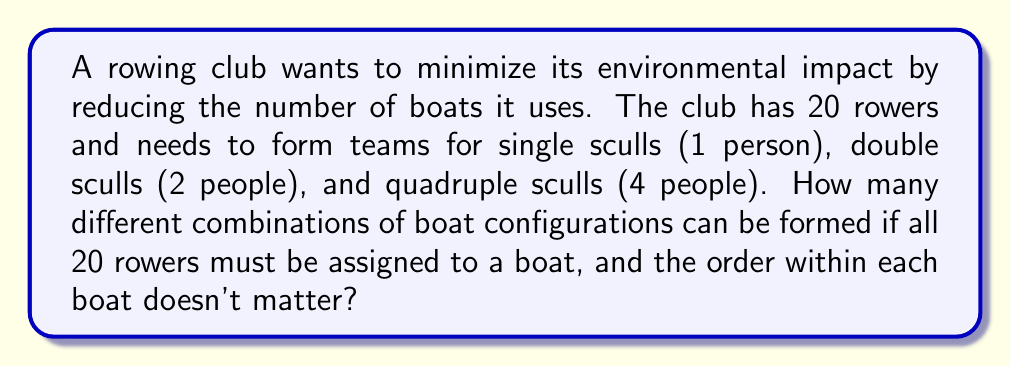Can you solve this math problem? Let's approach this step-by-step:

1) Let $x$, $y$, and $z$ represent the number of single, double, and quadruple sculls respectively.

2) We need to satisfy the equation: $x + 2y + 4z = 20$

3) Given the constraints, $x$, $y$, and $z$ must be non-negative integers.

4) We can list all possible combinations:
   $(x, y, z)$: $(20, 0, 0)$, $(18, 1, 0)$, $(16, 2, 0)$, $(14, 3, 0)$, $(12, 4, 0)$, $(10, 5, 0)$, 
   $(8, 6, 0)$, $(6, 7, 0)$, $(4, 8, 0)$, $(2, 9, 0)$, $(0, 10, 0)$, 
   $(16, 0, 1)$, $(14, 1, 1)$, $(12, 2, 1)$, $(10, 3, 1)$, $(8, 4, 1)$, $(6, 5, 1)$, $(4, 6, 1)$, $(2, 7, 1)$, $(0, 8, 1)$,
   $(12, 0, 2)$, $(10, 1, 2)$, $(8, 2, 2)$, $(6, 3, 2)$, $(4, 4, 2)$, $(2, 5, 2)$, $(0, 6, 2)$,
   $(8, 0, 3)$, $(6, 1, 3)$, $(4, 2, 3)$, $(2, 3, 3)$, $(0, 4, 3)$,
   $(4, 0, 4)$, $(2, 1, 4)$, $(0, 2, 4)$,
   $(0, 0, 5)$

5) Count the total number of combinations: There are 36 different boat configurations.

This approach ensures all rowers are assigned to a boat while considering all possible combinations of single, double, and quadruple sculls.
Answer: 36 